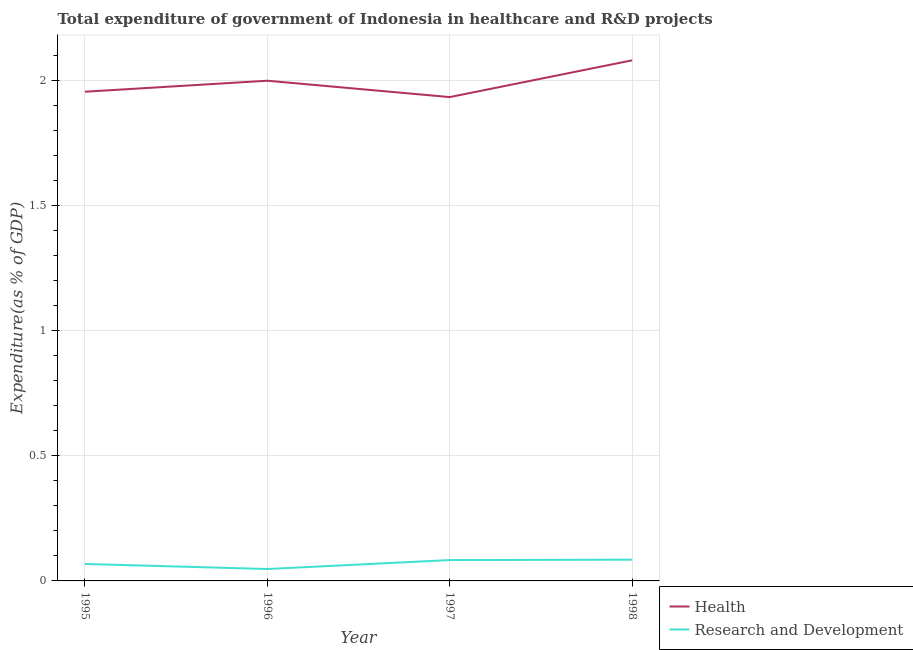What is the expenditure in r&d in 1996?
Provide a succinct answer. 0.05. Across all years, what is the maximum expenditure in healthcare?
Give a very brief answer. 2.08. Across all years, what is the minimum expenditure in healthcare?
Give a very brief answer. 1.93. In which year was the expenditure in healthcare maximum?
Make the answer very short. 1998. In which year was the expenditure in healthcare minimum?
Provide a short and direct response. 1997. What is the total expenditure in r&d in the graph?
Provide a succinct answer. 0.28. What is the difference between the expenditure in r&d in 1995 and that in 1998?
Offer a very short reply. -0.02. What is the difference between the expenditure in healthcare in 1996 and the expenditure in r&d in 1997?
Offer a very short reply. 1.91. What is the average expenditure in r&d per year?
Your answer should be compact. 0.07. In the year 1996, what is the difference between the expenditure in r&d and expenditure in healthcare?
Ensure brevity in your answer.  -1.95. What is the ratio of the expenditure in r&d in 1995 to that in 1997?
Keep it short and to the point. 0.81. Is the expenditure in r&d in 1996 less than that in 1997?
Your response must be concise. Yes. What is the difference between the highest and the second highest expenditure in r&d?
Offer a terse response. 0. What is the difference between the highest and the lowest expenditure in healthcare?
Provide a succinct answer. 0.15. In how many years, is the expenditure in r&d greater than the average expenditure in r&d taken over all years?
Provide a succinct answer. 2. Is the sum of the expenditure in r&d in 1995 and 1996 greater than the maximum expenditure in healthcare across all years?
Your answer should be very brief. No. Does the expenditure in r&d monotonically increase over the years?
Make the answer very short. No. Is the expenditure in r&d strictly greater than the expenditure in healthcare over the years?
Provide a short and direct response. No. How many lines are there?
Give a very brief answer. 2. How many years are there in the graph?
Make the answer very short. 4. Does the graph contain any zero values?
Your answer should be very brief. No. How many legend labels are there?
Your answer should be compact. 2. How are the legend labels stacked?
Your answer should be very brief. Vertical. What is the title of the graph?
Give a very brief answer. Total expenditure of government of Indonesia in healthcare and R&D projects. Does "International Tourists" appear as one of the legend labels in the graph?
Your answer should be very brief. No. What is the label or title of the Y-axis?
Provide a succinct answer. Expenditure(as % of GDP). What is the Expenditure(as % of GDP) in Health in 1995?
Provide a succinct answer. 1.95. What is the Expenditure(as % of GDP) in Research and Development in 1995?
Your answer should be compact. 0.07. What is the Expenditure(as % of GDP) in Health in 1996?
Offer a terse response. 2. What is the Expenditure(as % of GDP) of Research and Development in 1996?
Give a very brief answer. 0.05. What is the Expenditure(as % of GDP) of Health in 1997?
Your answer should be very brief. 1.93. What is the Expenditure(as % of GDP) in Research and Development in 1997?
Your response must be concise. 0.08. What is the Expenditure(as % of GDP) in Health in 1998?
Your answer should be compact. 2.08. What is the Expenditure(as % of GDP) of Research and Development in 1998?
Your answer should be very brief. 0.08. Across all years, what is the maximum Expenditure(as % of GDP) of Health?
Make the answer very short. 2.08. Across all years, what is the maximum Expenditure(as % of GDP) of Research and Development?
Your answer should be very brief. 0.08. Across all years, what is the minimum Expenditure(as % of GDP) of Health?
Your answer should be very brief. 1.93. Across all years, what is the minimum Expenditure(as % of GDP) of Research and Development?
Ensure brevity in your answer.  0.05. What is the total Expenditure(as % of GDP) in Health in the graph?
Ensure brevity in your answer.  7.96. What is the total Expenditure(as % of GDP) of Research and Development in the graph?
Keep it short and to the point. 0.28. What is the difference between the Expenditure(as % of GDP) of Health in 1995 and that in 1996?
Provide a succinct answer. -0.04. What is the difference between the Expenditure(as % of GDP) in Research and Development in 1995 and that in 1996?
Make the answer very short. 0.02. What is the difference between the Expenditure(as % of GDP) of Health in 1995 and that in 1997?
Provide a short and direct response. 0.02. What is the difference between the Expenditure(as % of GDP) in Research and Development in 1995 and that in 1997?
Make the answer very short. -0.02. What is the difference between the Expenditure(as % of GDP) in Health in 1995 and that in 1998?
Your answer should be very brief. -0.13. What is the difference between the Expenditure(as % of GDP) of Research and Development in 1995 and that in 1998?
Provide a short and direct response. -0.02. What is the difference between the Expenditure(as % of GDP) of Health in 1996 and that in 1997?
Offer a terse response. 0.07. What is the difference between the Expenditure(as % of GDP) of Research and Development in 1996 and that in 1997?
Offer a terse response. -0.04. What is the difference between the Expenditure(as % of GDP) in Health in 1996 and that in 1998?
Provide a succinct answer. -0.08. What is the difference between the Expenditure(as % of GDP) in Research and Development in 1996 and that in 1998?
Provide a succinct answer. -0.04. What is the difference between the Expenditure(as % of GDP) of Health in 1997 and that in 1998?
Offer a very short reply. -0.15. What is the difference between the Expenditure(as % of GDP) of Research and Development in 1997 and that in 1998?
Provide a short and direct response. -0. What is the difference between the Expenditure(as % of GDP) of Health in 1995 and the Expenditure(as % of GDP) of Research and Development in 1996?
Provide a succinct answer. 1.91. What is the difference between the Expenditure(as % of GDP) of Health in 1995 and the Expenditure(as % of GDP) of Research and Development in 1997?
Your response must be concise. 1.87. What is the difference between the Expenditure(as % of GDP) in Health in 1995 and the Expenditure(as % of GDP) in Research and Development in 1998?
Offer a terse response. 1.87. What is the difference between the Expenditure(as % of GDP) in Health in 1996 and the Expenditure(as % of GDP) in Research and Development in 1997?
Provide a short and direct response. 1.91. What is the difference between the Expenditure(as % of GDP) in Health in 1996 and the Expenditure(as % of GDP) in Research and Development in 1998?
Offer a terse response. 1.91. What is the difference between the Expenditure(as % of GDP) of Health in 1997 and the Expenditure(as % of GDP) of Research and Development in 1998?
Give a very brief answer. 1.85. What is the average Expenditure(as % of GDP) in Health per year?
Your answer should be compact. 1.99. What is the average Expenditure(as % of GDP) in Research and Development per year?
Your answer should be very brief. 0.07. In the year 1995, what is the difference between the Expenditure(as % of GDP) in Health and Expenditure(as % of GDP) in Research and Development?
Give a very brief answer. 1.89. In the year 1996, what is the difference between the Expenditure(as % of GDP) in Health and Expenditure(as % of GDP) in Research and Development?
Ensure brevity in your answer.  1.95. In the year 1997, what is the difference between the Expenditure(as % of GDP) of Health and Expenditure(as % of GDP) of Research and Development?
Your answer should be compact. 1.85. In the year 1998, what is the difference between the Expenditure(as % of GDP) in Health and Expenditure(as % of GDP) in Research and Development?
Ensure brevity in your answer.  1.99. What is the ratio of the Expenditure(as % of GDP) in Research and Development in 1995 to that in 1996?
Your response must be concise. 1.42. What is the ratio of the Expenditure(as % of GDP) of Health in 1995 to that in 1997?
Give a very brief answer. 1.01. What is the ratio of the Expenditure(as % of GDP) of Research and Development in 1995 to that in 1997?
Your response must be concise. 0.81. What is the ratio of the Expenditure(as % of GDP) of Health in 1995 to that in 1998?
Ensure brevity in your answer.  0.94. What is the ratio of the Expenditure(as % of GDP) of Research and Development in 1995 to that in 1998?
Provide a succinct answer. 0.8. What is the ratio of the Expenditure(as % of GDP) of Health in 1996 to that in 1997?
Your response must be concise. 1.03. What is the ratio of the Expenditure(as % of GDP) in Research and Development in 1996 to that in 1997?
Make the answer very short. 0.57. What is the ratio of the Expenditure(as % of GDP) in Health in 1996 to that in 1998?
Provide a short and direct response. 0.96. What is the ratio of the Expenditure(as % of GDP) of Research and Development in 1996 to that in 1998?
Provide a succinct answer. 0.56. What is the ratio of the Expenditure(as % of GDP) in Health in 1997 to that in 1998?
Keep it short and to the point. 0.93. What is the ratio of the Expenditure(as % of GDP) of Research and Development in 1997 to that in 1998?
Make the answer very short. 0.98. What is the difference between the highest and the second highest Expenditure(as % of GDP) in Health?
Keep it short and to the point. 0.08. What is the difference between the highest and the second highest Expenditure(as % of GDP) of Research and Development?
Provide a short and direct response. 0. What is the difference between the highest and the lowest Expenditure(as % of GDP) in Health?
Offer a terse response. 0.15. What is the difference between the highest and the lowest Expenditure(as % of GDP) in Research and Development?
Offer a very short reply. 0.04. 